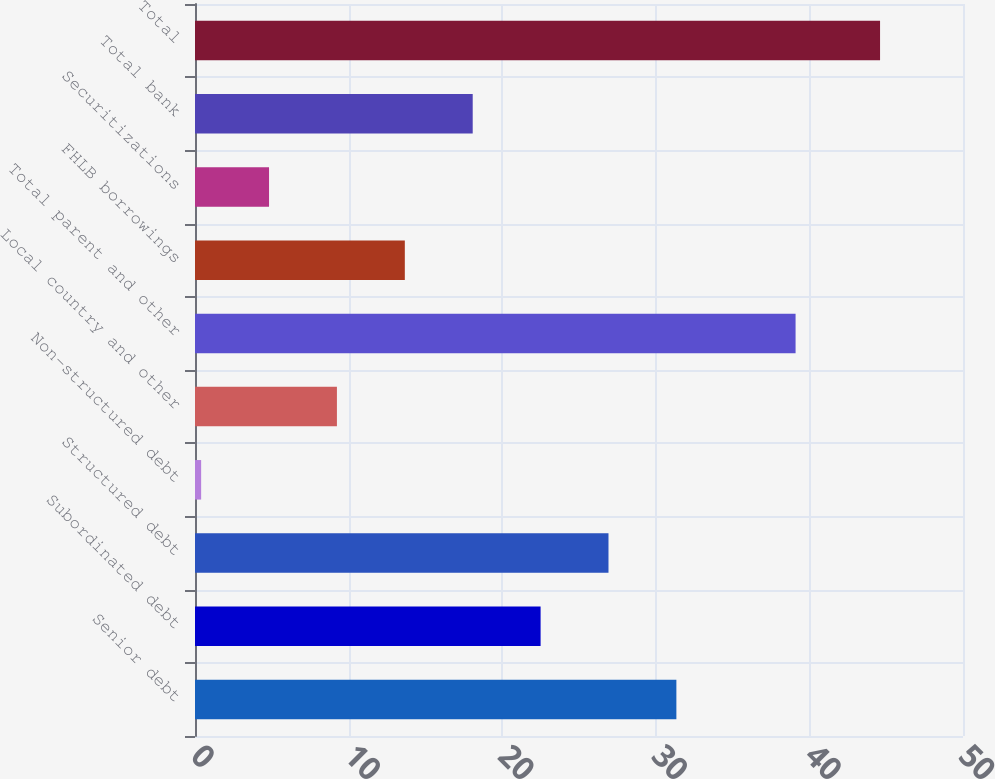Convert chart to OTSL. <chart><loc_0><loc_0><loc_500><loc_500><bar_chart><fcel>Senior debt<fcel>Subordinated debt<fcel>Structured debt<fcel>Non-structured debt<fcel>Local country and other<fcel>Total parent and other<fcel>FHLB borrowings<fcel>Securitizations<fcel>Total bank<fcel>Total<nl><fcel>31.34<fcel>22.5<fcel>26.92<fcel>0.4<fcel>9.24<fcel>39.1<fcel>13.66<fcel>4.82<fcel>18.08<fcel>44.6<nl></chart> 